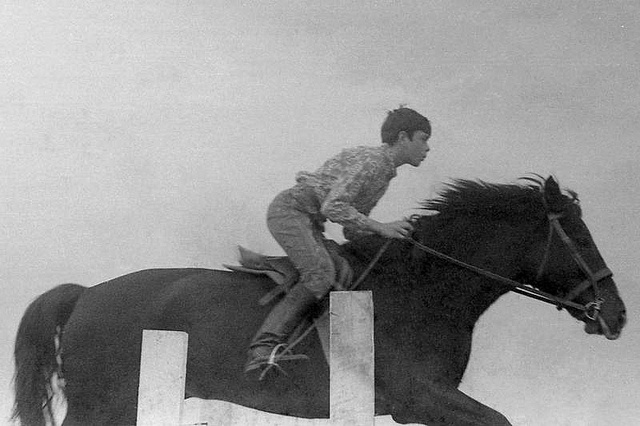Describe the objects in this image and their specific colors. I can see horse in lightgray, black, gray, and darkgray tones and people in lightgray, gray, black, and darkgray tones in this image. 